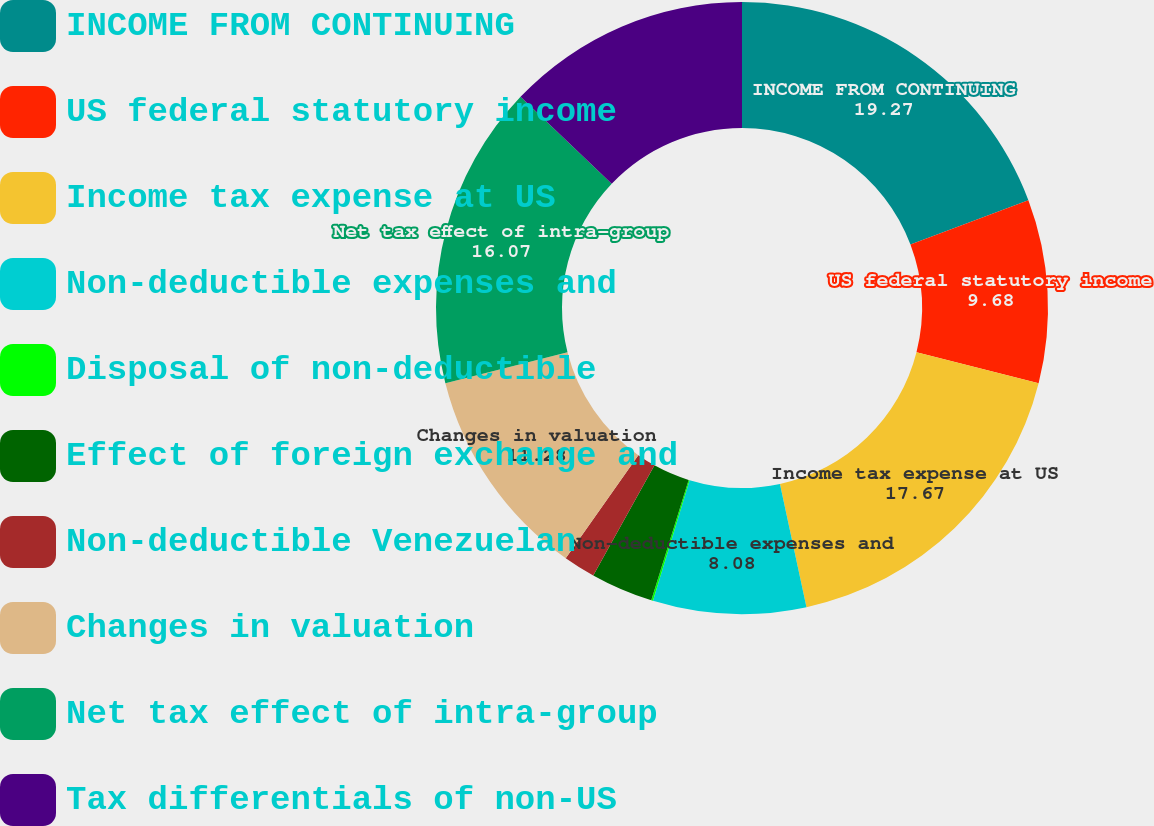<chart> <loc_0><loc_0><loc_500><loc_500><pie_chart><fcel>INCOME FROM CONTINUING<fcel>US federal statutory income<fcel>Income tax expense at US<fcel>Non-deductible expenses and<fcel>Disposal of non-deductible<fcel>Effect of foreign exchange and<fcel>Non-deductible Venezuelan<fcel>Changes in valuation<fcel>Net tax effect of intra-group<fcel>Tax differentials of non-US<nl><fcel>19.27%<fcel>9.68%<fcel>17.67%<fcel>8.08%<fcel>0.09%<fcel>3.29%<fcel>1.69%<fcel>11.28%<fcel>16.07%<fcel>12.88%<nl></chart> 